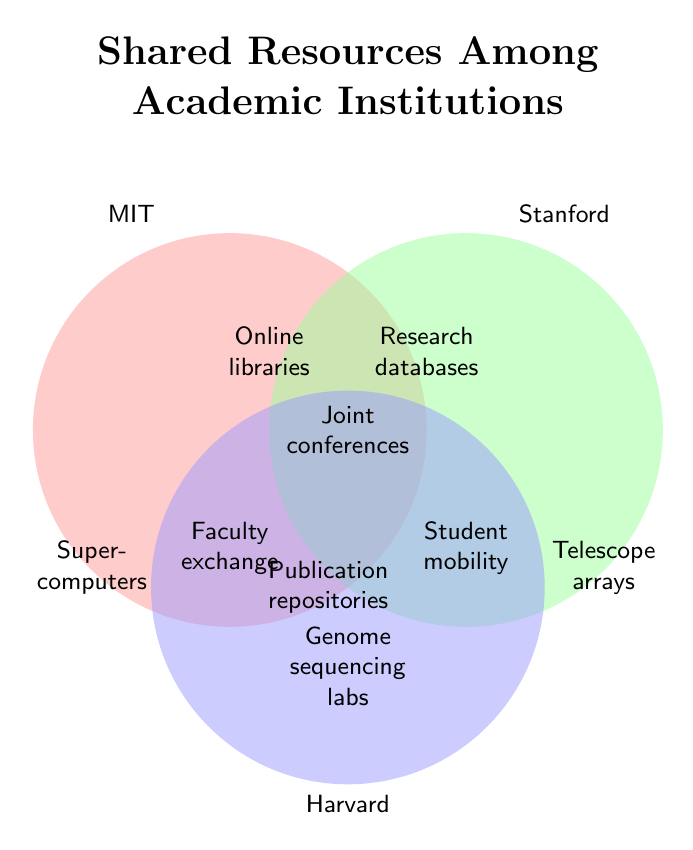What is the title of the figure? The title of the figure is usually displayed at the top and provides a summary of what the figure represents. Here, the title is "Shared Resources Among Academic Institutions".
Answer: Shared Resources Among Academic Institutions Which resource is shared by all three institutions? The center of the Venn Diagram where all three circles overlap shows the resources shared by all three institutions. This is labeled as "Joint conferences".
Answer: Joint conferences Which institution shares 'Supercomputers'? Each circle in the Venn Diagram represents an institution, and "Supercomputers" is within the circle labeled as "MIT".
Answer: MIT What resources are shared exclusively between MIT and Harvard? The overlap area between MIT and Harvard's circles, excluding Stanford's circle, shows the resources shared solely by these two institutions. This area is labeled "Faculty exchange".
Answer: Faculty exchange What resources are exclusive to Harvard? Resources that appear only within the circle of Harvard and do not overlap with either MIT or Stanford are counted. It shows "Genome sequencing labs".
Answer: Genome sequencing labs Which two institutions share 'Online libraries'? The area where MIT and Stanford circles intersect, excluding Harvard's circle, is labeled "Online libraries".
Answer: MIT and Stanford Which resource is shared between Stanford and Harvard but not MIT? The overlap area between Stanford and Harvard circles, excluding MIT's circle, shows the resources shared by these two but not MIT. This is labeled "Student mobility".
Answer: Student mobility List all resources shared by any two institutions. To find the resources shared by any two institutions, we need to look at all pairs' intersection areas but exclude the three-way intersection. These are: "Online libraries", "Faculty exchange", "Research databases", and "Student mobility".
Answer: Online libraries, Faculty exchange, Research databases, Student mobility Compare the number of shared resources among all three institutions to the number shared between MIT and Stanford. Which is greater? The count of resources in the area where all three circles overlap is compared with the overlap area of MIT and Stanford. "Joint conferences" (1) for all three versus "Online libraries" (1) for MIT and Stanford. Both counts are the same.
Answer: They are equal How many exclusive resources does each institution have? Count each resource within individual circles that do not overlap with others. MIT has "Supercomputers" (1), Stanford has "Telescope arrays" (1), and Harvard has "Genome sequencing labs" (1).
Answer: 1 each for MIT, Stanford, and Harvard 